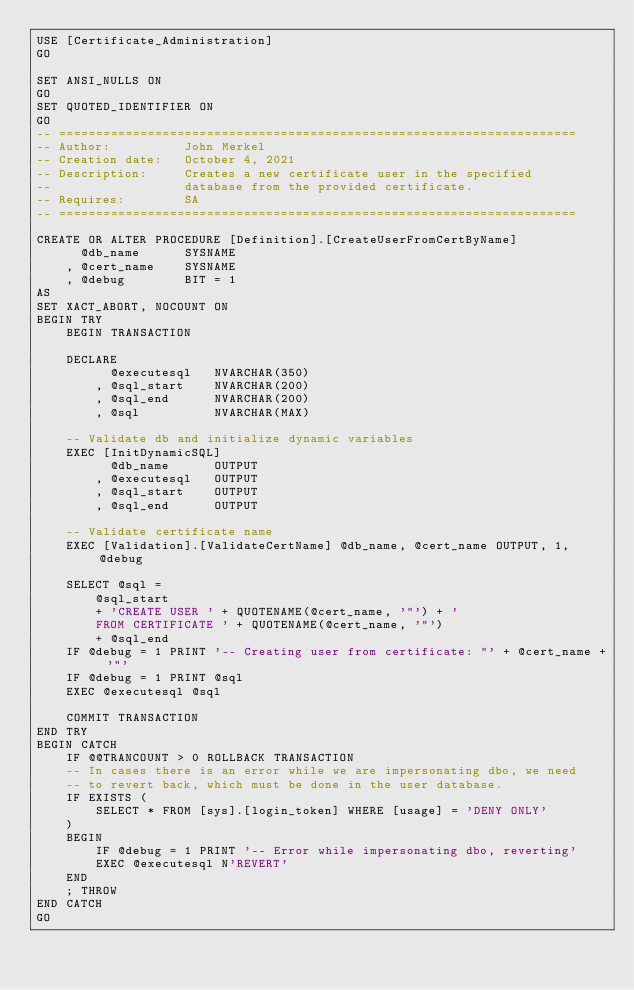Convert code to text. <code><loc_0><loc_0><loc_500><loc_500><_SQL_>USE [Certificate_Administration]
GO

SET ANSI_NULLS ON
GO
SET QUOTED_IDENTIFIER ON
GO
-- ======================================================================
-- Author:          John Merkel
-- Creation date:   October 4, 2021
-- Description:     Creates a new certificate user in the specified
--                  database from the provided certificate.
-- Requires:        SA
-- ======================================================================

CREATE OR ALTER PROCEDURE [Definition].[CreateUserFromCertByName]
      @db_name      SYSNAME
    , @cert_name    SYSNAME
    , @debug        BIT = 1
AS
SET XACT_ABORT, NOCOUNT ON
BEGIN TRY
    BEGIN TRANSACTION

    DECLARE
          @executesql   NVARCHAR(350)
        , @sql_start    NVARCHAR(200)
        , @sql_end      NVARCHAR(200)
        , @sql          NVARCHAR(MAX)

    -- Validate db and initialize dynamic variables
    EXEC [InitDynamicSQL]
          @db_name      OUTPUT
        , @executesql   OUTPUT
        , @sql_start    OUTPUT
        , @sql_end      OUTPUT

    -- Validate certificate name
    EXEC [Validation].[ValidateCertName] @db_name, @cert_name OUTPUT, 1, @debug

    SELECT @sql =
        @sql_start
        + 'CREATE USER ' + QUOTENAME(@cert_name, '"') + '
        FROM CERTIFICATE ' + QUOTENAME(@cert_name, '"')
        + @sql_end
    IF @debug = 1 PRINT '-- Creating user from certificate: "' + @cert_name + '"'
    IF @debug = 1 PRINT @sql
    EXEC @executesql @sql

    COMMIT TRANSACTION
END TRY
BEGIN CATCH
    IF @@TRANCOUNT > 0 ROLLBACK TRANSACTION
    -- In cases there is an error while we are impersonating dbo, we need
    -- to revert back, which must be done in the user database.
    IF EXISTS (
        SELECT * FROM [sys].[login_token] WHERE [usage] = 'DENY ONLY'
    )
    BEGIN
        IF @debug = 1 PRINT '-- Error while impersonating dbo, reverting'
        EXEC @executesql N'REVERT'
    END
    ; THROW
END CATCH
GO
</code> 